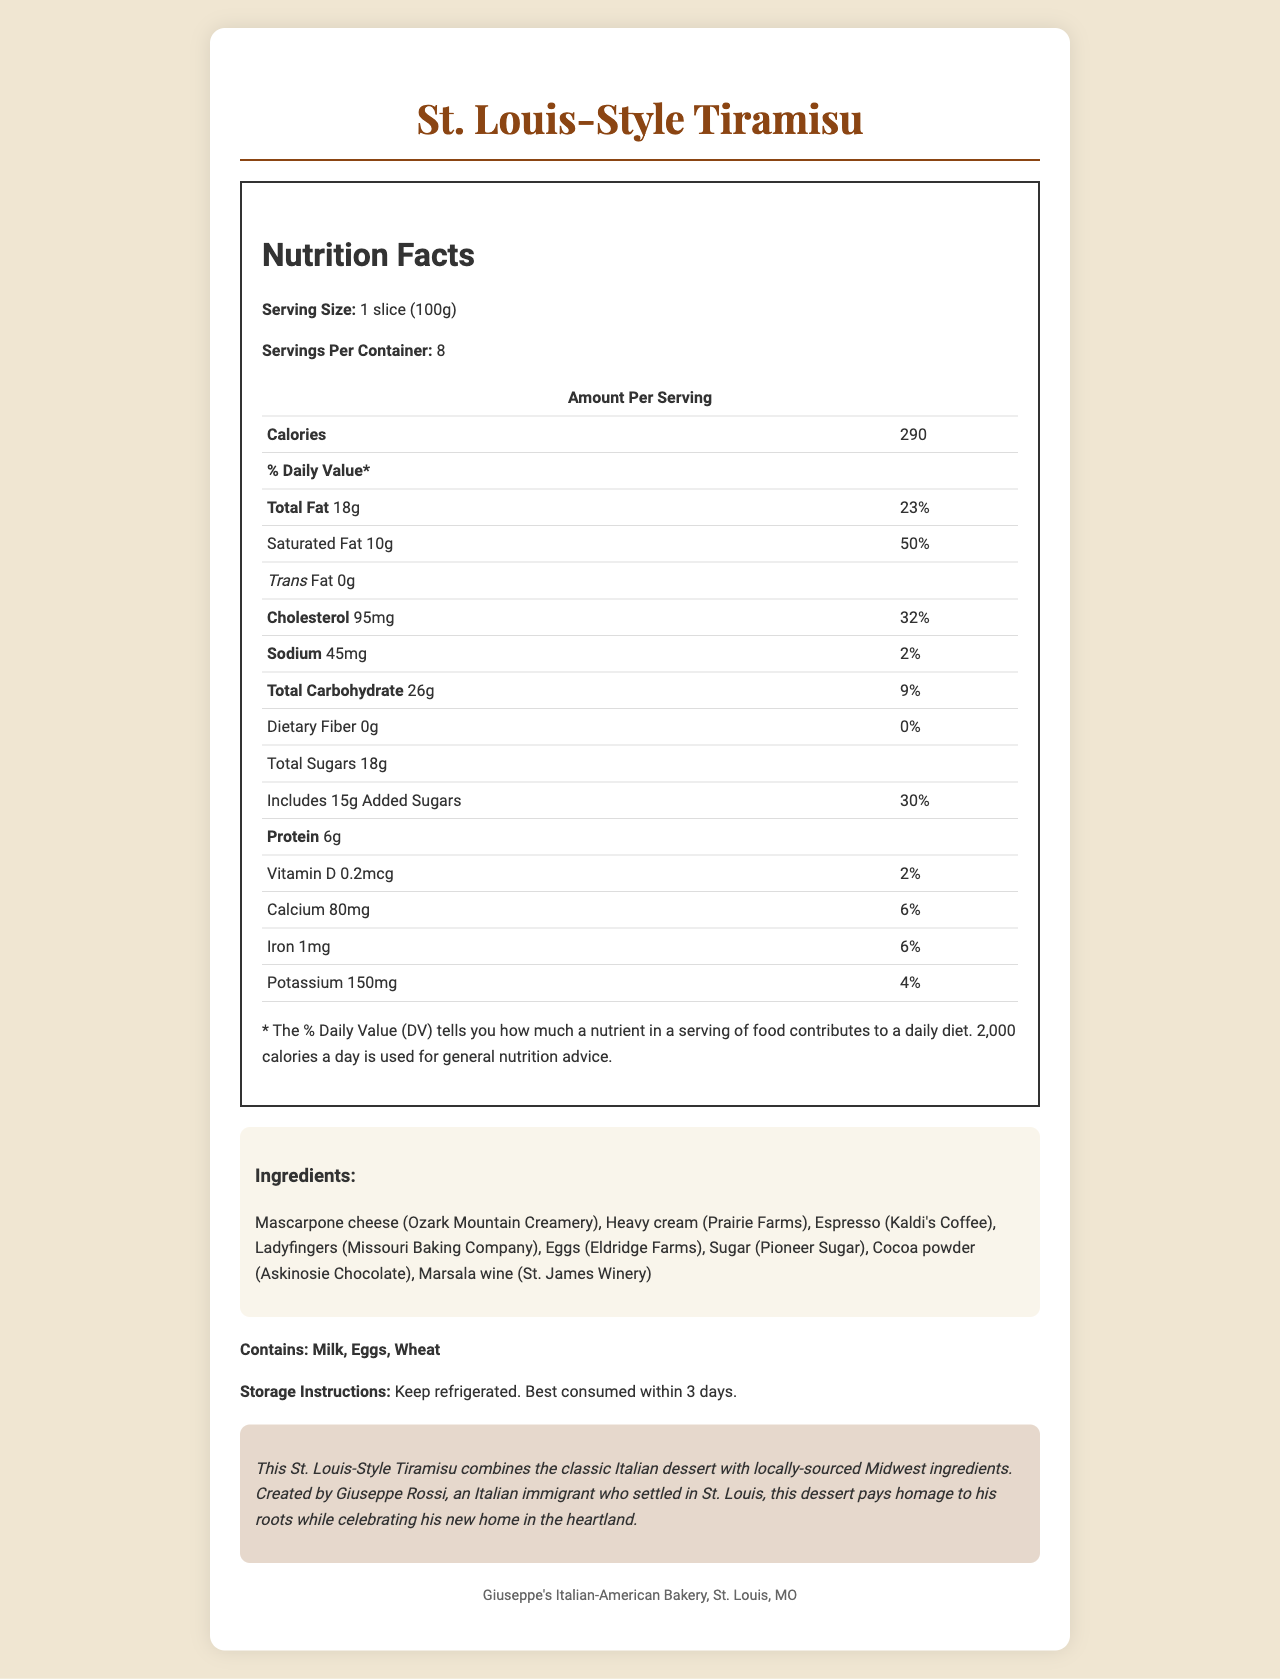what is the serving size for the St. Louis-Style Tiramisu? The serving size is specified in the document as "1 slice (100g)".
Answer: 1 slice (100g) how many calories are there per serving? The document states that each serving contains 290 calories.
Answer: 290 what are the total sugars in one serving? The document lists total sugars per serving as 18 grams.
Answer: 18g what ingredients are used to make the Tiramisu? The ingredients are detailed in a list in the ingredients section of the document.
Answer: Mascarpone cheese, Heavy cream, Espresso, Ladyfingers, Eggs, Sugar, Cocoa powder, Marsala wine what is the daily value percentage for added sugars? According to the nutrition label, added sugars have a daily value percentage of 30%.
Answer: 30% how many servings are in the container? The servings per container is listed as 8.
Answer: 8 which of these allergens does the Tiramisu contain? A. Milk B. Nuts C. Soy D. Eggs The allergens section lists Milk, Eggs, and Wheat as the allergens present in the Tiramisu.
Answer: A. Milk and D. Eggs what is the total fat content in one serving? A. 10g B. 18g C. 26g The total fat content is specified as 18 grams per serving.
Answer: B. 18g which local ingredients are used in the Tiramisu? A. Askinosie Chocolate B. Kaldi's Coffee C. Missouri Baking Company D. All of the above The document lists these local sources in the ingredients section for cocoa powder (Askinosie Chocolate), espresso (Kaldi's Coffee), and ladyfingers (Missouri Baking Company).
Answer: D. All of the above is the Tiramisu gluten-free? The Tiramisu contains wheat, as indicated in the allergens section.
Answer: No describe the main idea of the document. The document includes a nutrition facts label, list of ingredients, allergens, storage instructions, a story about the product's creation, and manufacturer information, offering a comprehensive overview of the dessert.
Answer: The document provides detailed nutritional information, ingredient sourcing, and background for a locally adapted version of the classic Italian dessert Tiramisu, called St. Louis-Style Tiramisu. It highlights the combination of traditional Italian elements and locally-sourced Midwestern ingredients. where can I buy the ingredients used in the Tiramisu? The document does not specify where the ingredients can be purchased, only that they are locally sourced from specific places.
Answer: Not enough information 